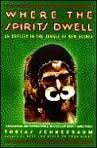What cultures does the author explore in 'Where the Spirits Dwell'? The author, Tobias Schneebaum, dives deep into exploring the native cultures of New Guinea, particularly focusing on their traditions, rituals, and way of life in the jungle. 